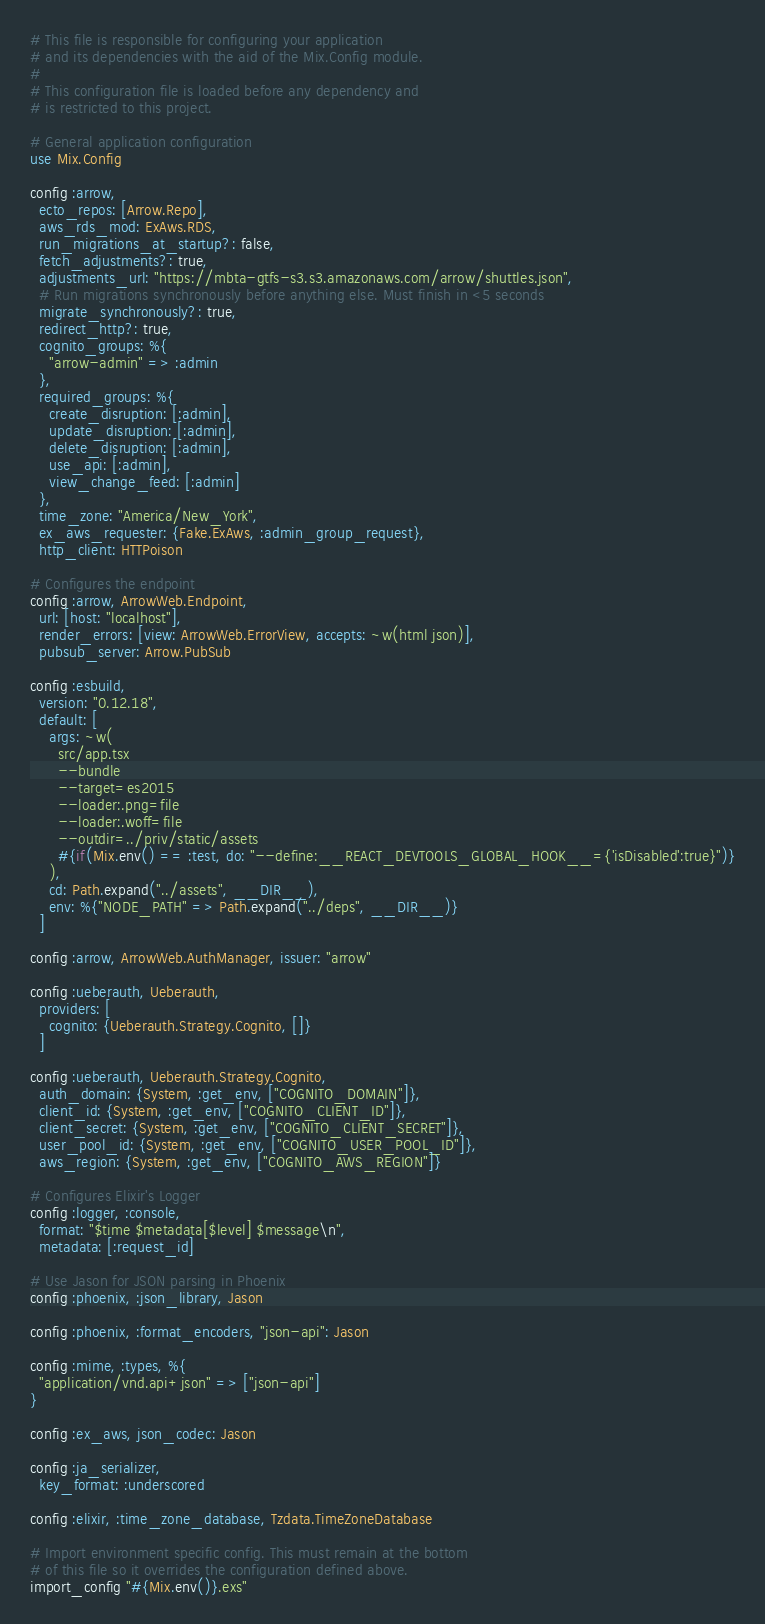<code> <loc_0><loc_0><loc_500><loc_500><_Elixir_># This file is responsible for configuring your application
# and its dependencies with the aid of the Mix.Config module.
#
# This configuration file is loaded before any dependency and
# is restricted to this project.

# General application configuration
use Mix.Config

config :arrow,
  ecto_repos: [Arrow.Repo],
  aws_rds_mod: ExAws.RDS,
  run_migrations_at_startup?: false,
  fetch_adjustments?: true,
  adjustments_url: "https://mbta-gtfs-s3.s3.amazonaws.com/arrow/shuttles.json",
  # Run migrations synchronously before anything else. Must finish in <5 seconds
  migrate_synchronously?: true,
  redirect_http?: true,
  cognito_groups: %{
    "arrow-admin" => :admin
  },
  required_groups: %{
    create_disruption: [:admin],
    update_disruption: [:admin],
    delete_disruption: [:admin],
    use_api: [:admin],
    view_change_feed: [:admin]
  },
  time_zone: "America/New_York",
  ex_aws_requester: {Fake.ExAws, :admin_group_request},
  http_client: HTTPoison

# Configures the endpoint
config :arrow, ArrowWeb.Endpoint,
  url: [host: "localhost"],
  render_errors: [view: ArrowWeb.ErrorView, accepts: ~w(html json)],
  pubsub_server: Arrow.PubSub

config :esbuild,
  version: "0.12.18",
  default: [
    args: ~w(
      src/app.tsx
      --bundle
      --target=es2015
      --loader:.png=file
      --loader:.woff=file
      --outdir=../priv/static/assets
      #{if(Mix.env() == :test, do: "--define:__REACT_DEVTOOLS_GLOBAL_HOOK__={'isDisabled':true}")}
    ),
    cd: Path.expand("../assets", __DIR__),
    env: %{"NODE_PATH" => Path.expand("../deps", __DIR__)}
  ]

config :arrow, ArrowWeb.AuthManager, issuer: "arrow"

config :ueberauth, Ueberauth,
  providers: [
    cognito: {Ueberauth.Strategy.Cognito, []}
  ]

config :ueberauth, Ueberauth.Strategy.Cognito,
  auth_domain: {System, :get_env, ["COGNITO_DOMAIN"]},
  client_id: {System, :get_env, ["COGNITO_CLIENT_ID"]},
  client_secret: {System, :get_env, ["COGNITO_CLIENT_SECRET"]},
  user_pool_id: {System, :get_env, ["COGNITO_USER_POOL_ID"]},
  aws_region: {System, :get_env, ["COGNITO_AWS_REGION"]}

# Configures Elixir's Logger
config :logger, :console,
  format: "$time $metadata[$level] $message\n",
  metadata: [:request_id]

# Use Jason for JSON parsing in Phoenix
config :phoenix, :json_library, Jason

config :phoenix, :format_encoders, "json-api": Jason

config :mime, :types, %{
  "application/vnd.api+json" => ["json-api"]
}

config :ex_aws, json_codec: Jason

config :ja_serializer,
  key_format: :underscored

config :elixir, :time_zone_database, Tzdata.TimeZoneDatabase

# Import environment specific config. This must remain at the bottom
# of this file so it overrides the configuration defined above.
import_config "#{Mix.env()}.exs"
</code> 